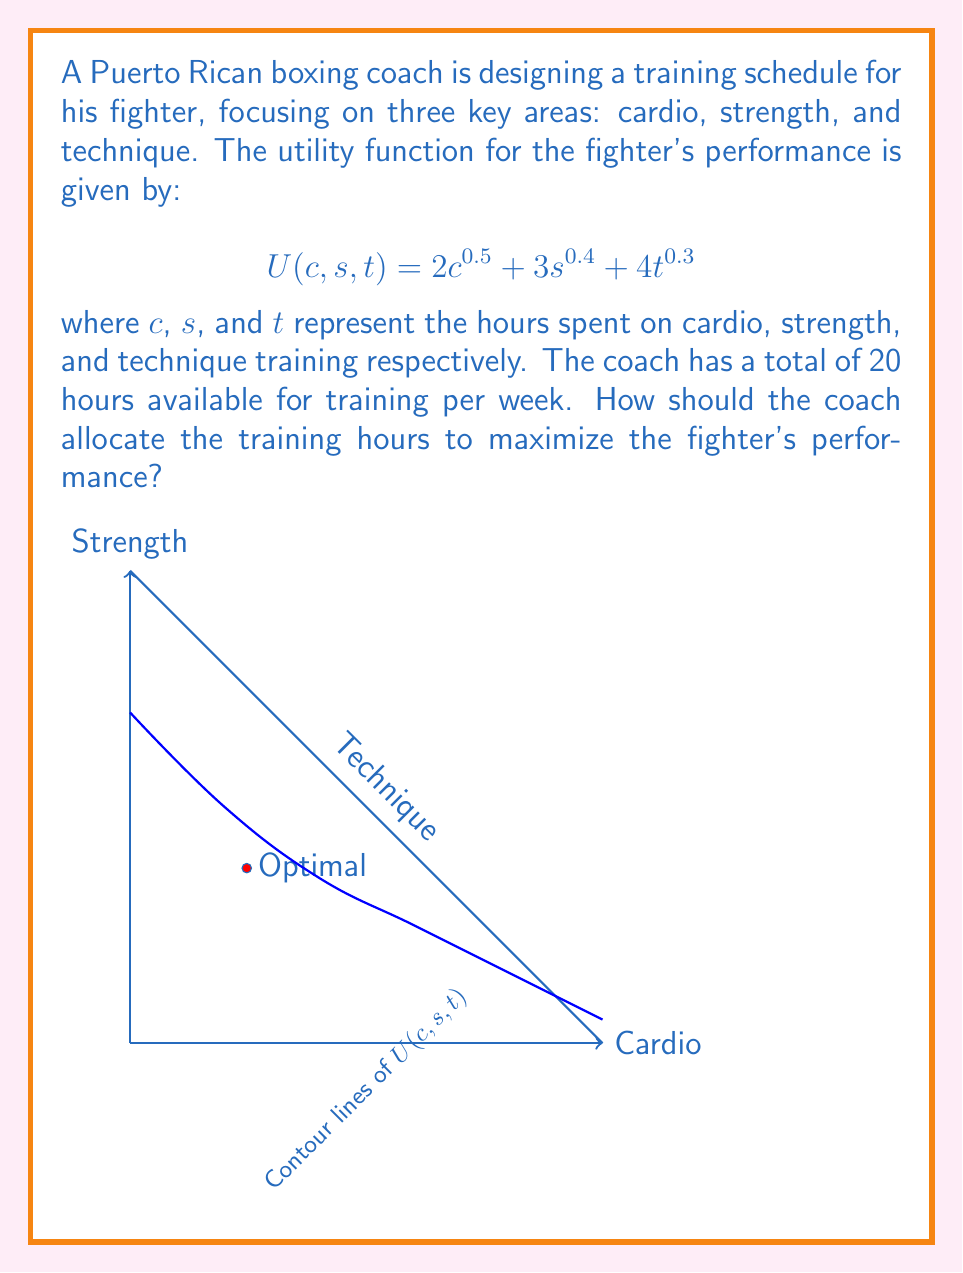Teach me how to tackle this problem. To solve this optimization problem, we'll use the method of Lagrange multipliers:

1) First, we set up the Lagrangian function:
   $$L(c, s, t, λ) = 2c^{0.5} + 3s^{0.4} + 4t^{0.3} - λ(c + s + t - 20)$$

2) Now, we take partial derivatives and set them equal to zero:

   $$\frac{∂L}{∂c} = c^{-0.5} - λ = 0$$
   $$\frac{∂L}{∂s} = 1.2s^{-0.6} - λ = 0$$
   $$\frac{∂L}{∂t} = 1.2t^{-0.7} - λ = 0$$
   $$\frac{∂L}{∂λ} = c + s + t - 20 = 0$$

3) From these equations, we can derive:
   $$c^{-0.5} = 1.2s^{-0.6} = 1.2t^{-0.7} = λ$$

4) This gives us the proportions:
   $$c : s : t = 1^2 : (1.2)^{5/3} : (1.2)^{7/3} ≈ 1 : 1.5 : 2.1$$

5) Given the total of 20 hours, we can solve:
   $$c + 1.5c + 2.1c = 20$$
   $$4.6c = 20$$
   $$c ≈ 4.35$$

6) From this, we can calculate s and t:
   $$s ≈ 1.5 * 4.35 ≈ 6.52$$
   $$t ≈ 2.1 * 4.35 ≈ 9.13$$

7) Rounding to the nearest quarter hour for practicality:
   Cardio (c) = 4.25 hours
   Strength (s) = 6.5 hours
   Technique (t) = 9.25 hours
Answer: Cardio: 4.25 hours, Strength: 6.5 hours, Technique: 9.25 hours 